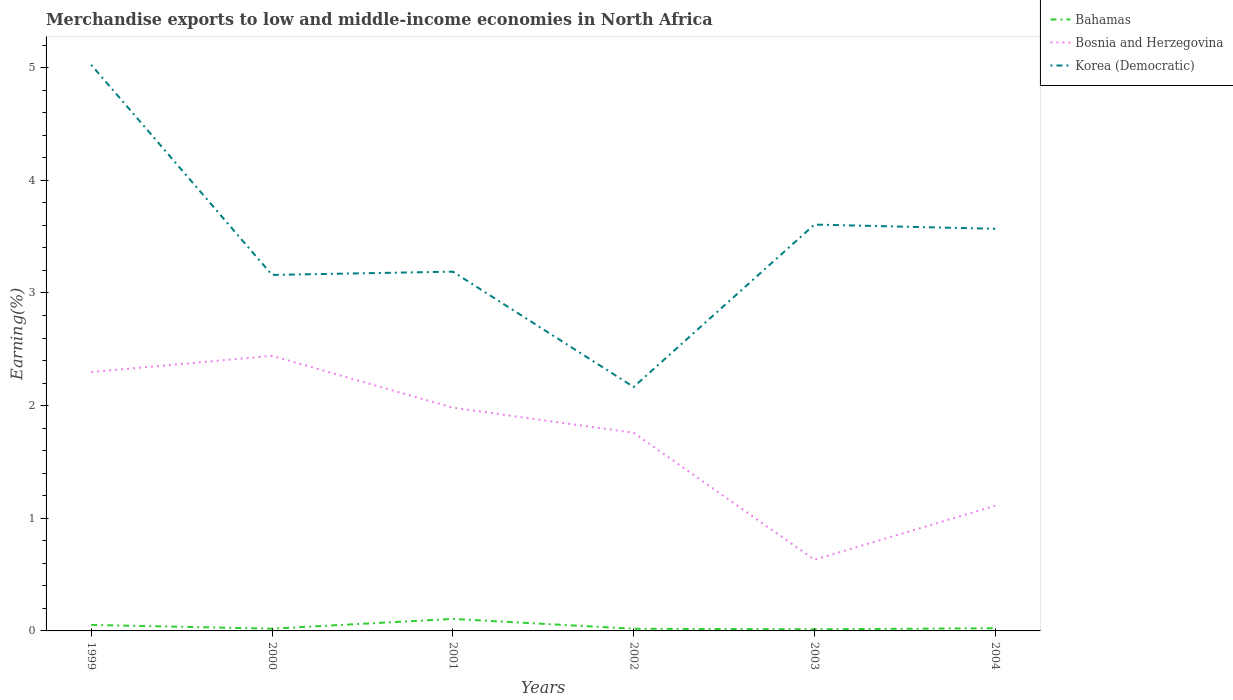Is the number of lines equal to the number of legend labels?
Your answer should be very brief. Yes. Across all years, what is the maximum percentage of amount earned from merchandise exports in Bosnia and Herzegovina?
Keep it short and to the point. 0.63. In which year was the percentage of amount earned from merchandise exports in Bahamas maximum?
Give a very brief answer. 2003. What is the total percentage of amount earned from merchandise exports in Korea (Democratic) in the graph?
Provide a short and direct response. 1.84. What is the difference between the highest and the second highest percentage of amount earned from merchandise exports in Bosnia and Herzegovina?
Give a very brief answer. 1.81. What is the difference between the highest and the lowest percentage of amount earned from merchandise exports in Bosnia and Herzegovina?
Your response must be concise. 4. Is the percentage of amount earned from merchandise exports in Bahamas strictly greater than the percentage of amount earned from merchandise exports in Bosnia and Herzegovina over the years?
Your answer should be compact. Yes. How many lines are there?
Provide a succinct answer. 3. What is the difference between two consecutive major ticks on the Y-axis?
Make the answer very short. 1. Does the graph contain any zero values?
Make the answer very short. No. How many legend labels are there?
Your response must be concise. 3. What is the title of the graph?
Offer a very short reply. Merchandise exports to low and middle-income economies in North Africa. What is the label or title of the Y-axis?
Give a very brief answer. Earning(%). What is the Earning(%) of Bahamas in 1999?
Give a very brief answer. 0.05. What is the Earning(%) in Bosnia and Herzegovina in 1999?
Your answer should be very brief. 2.3. What is the Earning(%) in Korea (Democratic) in 1999?
Your answer should be compact. 5.02. What is the Earning(%) of Bahamas in 2000?
Offer a very short reply. 0.02. What is the Earning(%) of Bosnia and Herzegovina in 2000?
Keep it short and to the point. 2.44. What is the Earning(%) in Korea (Democratic) in 2000?
Your answer should be compact. 3.16. What is the Earning(%) of Bahamas in 2001?
Provide a short and direct response. 0.11. What is the Earning(%) in Bosnia and Herzegovina in 2001?
Offer a very short reply. 1.98. What is the Earning(%) in Korea (Democratic) in 2001?
Ensure brevity in your answer.  3.19. What is the Earning(%) in Bahamas in 2002?
Offer a terse response. 0.02. What is the Earning(%) in Bosnia and Herzegovina in 2002?
Offer a very short reply. 1.76. What is the Earning(%) in Korea (Democratic) in 2002?
Offer a very short reply. 2.17. What is the Earning(%) of Bahamas in 2003?
Make the answer very short. 0.01. What is the Earning(%) in Bosnia and Herzegovina in 2003?
Ensure brevity in your answer.  0.63. What is the Earning(%) in Korea (Democratic) in 2003?
Provide a succinct answer. 3.61. What is the Earning(%) of Bahamas in 2004?
Your answer should be compact. 0.02. What is the Earning(%) in Bosnia and Herzegovina in 2004?
Provide a short and direct response. 1.11. What is the Earning(%) in Korea (Democratic) in 2004?
Your answer should be compact. 3.57. Across all years, what is the maximum Earning(%) of Bahamas?
Give a very brief answer. 0.11. Across all years, what is the maximum Earning(%) of Bosnia and Herzegovina?
Give a very brief answer. 2.44. Across all years, what is the maximum Earning(%) of Korea (Democratic)?
Your response must be concise. 5.02. Across all years, what is the minimum Earning(%) of Bahamas?
Make the answer very short. 0.01. Across all years, what is the minimum Earning(%) in Bosnia and Herzegovina?
Make the answer very short. 0.63. Across all years, what is the minimum Earning(%) of Korea (Democratic)?
Offer a very short reply. 2.17. What is the total Earning(%) of Bahamas in the graph?
Give a very brief answer. 0.24. What is the total Earning(%) of Bosnia and Herzegovina in the graph?
Provide a succinct answer. 10.22. What is the total Earning(%) in Korea (Democratic) in the graph?
Offer a very short reply. 20.72. What is the difference between the Earning(%) of Bahamas in 1999 and that in 2000?
Offer a terse response. 0.03. What is the difference between the Earning(%) in Bosnia and Herzegovina in 1999 and that in 2000?
Provide a succinct answer. -0.14. What is the difference between the Earning(%) in Korea (Democratic) in 1999 and that in 2000?
Your response must be concise. 1.87. What is the difference between the Earning(%) of Bahamas in 1999 and that in 2001?
Offer a terse response. -0.05. What is the difference between the Earning(%) in Bosnia and Herzegovina in 1999 and that in 2001?
Keep it short and to the point. 0.32. What is the difference between the Earning(%) in Korea (Democratic) in 1999 and that in 2001?
Your response must be concise. 1.84. What is the difference between the Earning(%) of Bahamas in 1999 and that in 2002?
Make the answer very short. 0.03. What is the difference between the Earning(%) in Bosnia and Herzegovina in 1999 and that in 2002?
Give a very brief answer. 0.54. What is the difference between the Earning(%) of Korea (Democratic) in 1999 and that in 2002?
Keep it short and to the point. 2.86. What is the difference between the Earning(%) in Bahamas in 1999 and that in 2003?
Provide a succinct answer. 0.04. What is the difference between the Earning(%) of Bosnia and Herzegovina in 1999 and that in 2003?
Provide a succinct answer. 1.67. What is the difference between the Earning(%) in Korea (Democratic) in 1999 and that in 2003?
Offer a very short reply. 1.42. What is the difference between the Earning(%) in Bahamas in 1999 and that in 2004?
Keep it short and to the point. 0.03. What is the difference between the Earning(%) in Bosnia and Herzegovina in 1999 and that in 2004?
Offer a very short reply. 1.19. What is the difference between the Earning(%) of Korea (Democratic) in 1999 and that in 2004?
Make the answer very short. 1.46. What is the difference between the Earning(%) of Bahamas in 2000 and that in 2001?
Ensure brevity in your answer.  -0.09. What is the difference between the Earning(%) in Bosnia and Herzegovina in 2000 and that in 2001?
Ensure brevity in your answer.  0.46. What is the difference between the Earning(%) of Korea (Democratic) in 2000 and that in 2001?
Your response must be concise. -0.03. What is the difference between the Earning(%) in Bahamas in 2000 and that in 2002?
Make the answer very short. 0. What is the difference between the Earning(%) in Bosnia and Herzegovina in 2000 and that in 2002?
Make the answer very short. 0.68. What is the difference between the Earning(%) of Bahamas in 2000 and that in 2003?
Offer a terse response. 0.01. What is the difference between the Earning(%) in Bosnia and Herzegovina in 2000 and that in 2003?
Provide a succinct answer. 1.81. What is the difference between the Earning(%) in Korea (Democratic) in 2000 and that in 2003?
Give a very brief answer. -0.45. What is the difference between the Earning(%) of Bahamas in 2000 and that in 2004?
Ensure brevity in your answer.  -0. What is the difference between the Earning(%) in Bosnia and Herzegovina in 2000 and that in 2004?
Provide a succinct answer. 1.33. What is the difference between the Earning(%) of Korea (Democratic) in 2000 and that in 2004?
Provide a succinct answer. -0.41. What is the difference between the Earning(%) in Bahamas in 2001 and that in 2002?
Offer a very short reply. 0.09. What is the difference between the Earning(%) of Bosnia and Herzegovina in 2001 and that in 2002?
Your answer should be compact. 0.22. What is the difference between the Earning(%) in Korea (Democratic) in 2001 and that in 2002?
Give a very brief answer. 1.02. What is the difference between the Earning(%) of Bahamas in 2001 and that in 2003?
Provide a short and direct response. 0.09. What is the difference between the Earning(%) of Bosnia and Herzegovina in 2001 and that in 2003?
Your answer should be very brief. 1.35. What is the difference between the Earning(%) of Korea (Democratic) in 2001 and that in 2003?
Give a very brief answer. -0.42. What is the difference between the Earning(%) of Bahamas in 2001 and that in 2004?
Offer a very short reply. 0.08. What is the difference between the Earning(%) of Bosnia and Herzegovina in 2001 and that in 2004?
Your answer should be compact. 0.87. What is the difference between the Earning(%) of Korea (Democratic) in 2001 and that in 2004?
Provide a short and direct response. -0.38. What is the difference between the Earning(%) of Bahamas in 2002 and that in 2003?
Keep it short and to the point. 0. What is the difference between the Earning(%) in Bosnia and Herzegovina in 2002 and that in 2003?
Offer a very short reply. 1.13. What is the difference between the Earning(%) of Korea (Democratic) in 2002 and that in 2003?
Your answer should be compact. -1.44. What is the difference between the Earning(%) of Bahamas in 2002 and that in 2004?
Ensure brevity in your answer.  -0. What is the difference between the Earning(%) in Bosnia and Herzegovina in 2002 and that in 2004?
Keep it short and to the point. 0.65. What is the difference between the Earning(%) in Korea (Democratic) in 2002 and that in 2004?
Offer a very short reply. -1.4. What is the difference between the Earning(%) of Bahamas in 2003 and that in 2004?
Keep it short and to the point. -0.01. What is the difference between the Earning(%) of Bosnia and Herzegovina in 2003 and that in 2004?
Offer a terse response. -0.48. What is the difference between the Earning(%) of Korea (Democratic) in 2003 and that in 2004?
Give a very brief answer. 0.04. What is the difference between the Earning(%) of Bahamas in 1999 and the Earning(%) of Bosnia and Herzegovina in 2000?
Your answer should be compact. -2.39. What is the difference between the Earning(%) in Bahamas in 1999 and the Earning(%) in Korea (Democratic) in 2000?
Provide a short and direct response. -3.11. What is the difference between the Earning(%) of Bosnia and Herzegovina in 1999 and the Earning(%) of Korea (Democratic) in 2000?
Provide a short and direct response. -0.86. What is the difference between the Earning(%) of Bahamas in 1999 and the Earning(%) of Bosnia and Herzegovina in 2001?
Make the answer very short. -1.93. What is the difference between the Earning(%) of Bahamas in 1999 and the Earning(%) of Korea (Democratic) in 2001?
Your response must be concise. -3.14. What is the difference between the Earning(%) of Bosnia and Herzegovina in 1999 and the Earning(%) of Korea (Democratic) in 2001?
Offer a terse response. -0.89. What is the difference between the Earning(%) in Bahamas in 1999 and the Earning(%) in Bosnia and Herzegovina in 2002?
Provide a succinct answer. -1.71. What is the difference between the Earning(%) of Bahamas in 1999 and the Earning(%) of Korea (Democratic) in 2002?
Ensure brevity in your answer.  -2.11. What is the difference between the Earning(%) of Bosnia and Herzegovina in 1999 and the Earning(%) of Korea (Democratic) in 2002?
Your answer should be compact. 0.13. What is the difference between the Earning(%) of Bahamas in 1999 and the Earning(%) of Bosnia and Herzegovina in 2003?
Offer a terse response. -0.58. What is the difference between the Earning(%) of Bahamas in 1999 and the Earning(%) of Korea (Democratic) in 2003?
Keep it short and to the point. -3.55. What is the difference between the Earning(%) in Bosnia and Herzegovina in 1999 and the Earning(%) in Korea (Democratic) in 2003?
Ensure brevity in your answer.  -1.31. What is the difference between the Earning(%) of Bahamas in 1999 and the Earning(%) of Bosnia and Herzegovina in 2004?
Offer a very short reply. -1.06. What is the difference between the Earning(%) of Bahamas in 1999 and the Earning(%) of Korea (Democratic) in 2004?
Offer a terse response. -3.52. What is the difference between the Earning(%) of Bosnia and Herzegovina in 1999 and the Earning(%) of Korea (Democratic) in 2004?
Ensure brevity in your answer.  -1.27. What is the difference between the Earning(%) of Bahamas in 2000 and the Earning(%) of Bosnia and Herzegovina in 2001?
Your response must be concise. -1.96. What is the difference between the Earning(%) in Bahamas in 2000 and the Earning(%) in Korea (Democratic) in 2001?
Offer a very short reply. -3.17. What is the difference between the Earning(%) in Bosnia and Herzegovina in 2000 and the Earning(%) in Korea (Democratic) in 2001?
Make the answer very short. -0.75. What is the difference between the Earning(%) of Bahamas in 2000 and the Earning(%) of Bosnia and Herzegovina in 2002?
Ensure brevity in your answer.  -1.74. What is the difference between the Earning(%) of Bahamas in 2000 and the Earning(%) of Korea (Democratic) in 2002?
Make the answer very short. -2.15. What is the difference between the Earning(%) of Bosnia and Herzegovina in 2000 and the Earning(%) of Korea (Democratic) in 2002?
Offer a very short reply. 0.28. What is the difference between the Earning(%) in Bahamas in 2000 and the Earning(%) in Bosnia and Herzegovina in 2003?
Keep it short and to the point. -0.61. What is the difference between the Earning(%) in Bahamas in 2000 and the Earning(%) in Korea (Democratic) in 2003?
Your response must be concise. -3.59. What is the difference between the Earning(%) of Bosnia and Herzegovina in 2000 and the Earning(%) of Korea (Democratic) in 2003?
Provide a succinct answer. -1.17. What is the difference between the Earning(%) of Bahamas in 2000 and the Earning(%) of Bosnia and Herzegovina in 2004?
Provide a succinct answer. -1.09. What is the difference between the Earning(%) in Bahamas in 2000 and the Earning(%) in Korea (Democratic) in 2004?
Offer a very short reply. -3.55. What is the difference between the Earning(%) in Bosnia and Herzegovina in 2000 and the Earning(%) in Korea (Democratic) in 2004?
Your answer should be very brief. -1.13. What is the difference between the Earning(%) of Bahamas in 2001 and the Earning(%) of Bosnia and Herzegovina in 2002?
Your answer should be very brief. -1.65. What is the difference between the Earning(%) of Bahamas in 2001 and the Earning(%) of Korea (Democratic) in 2002?
Offer a very short reply. -2.06. What is the difference between the Earning(%) of Bosnia and Herzegovina in 2001 and the Earning(%) of Korea (Democratic) in 2002?
Make the answer very short. -0.18. What is the difference between the Earning(%) in Bahamas in 2001 and the Earning(%) in Bosnia and Herzegovina in 2003?
Ensure brevity in your answer.  -0.53. What is the difference between the Earning(%) of Bahamas in 2001 and the Earning(%) of Korea (Democratic) in 2003?
Your response must be concise. -3.5. What is the difference between the Earning(%) in Bosnia and Herzegovina in 2001 and the Earning(%) in Korea (Democratic) in 2003?
Offer a very short reply. -1.63. What is the difference between the Earning(%) of Bahamas in 2001 and the Earning(%) of Bosnia and Herzegovina in 2004?
Make the answer very short. -1. What is the difference between the Earning(%) in Bahamas in 2001 and the Earning(%) in Korea (Democratic) in 2004?
Offer a terse response. -3.46. What is the difference between the Earning(%) of Bosnia and Herzegovina in 2001 and the Earning(%) of Korea (Democratic) in 2004?
Provide a short and direct response. -1.59. What is the difference between the Earning(%) in Bahamas in 2002 and the Earning(%) in Bosnia and Herzegovina in 2003?
Your response must be concise. -0.61. What is the difference between the Earning(%) of Bahamas in 2002 and the Earning(%) of Korea (Democratic) in 2003?
Your answer should be very brief. -3.59. What is the difference between the Earning(%) of Bosnia and Herzegovina in 2002 and the Earning(%) of Korea (Democratic) in 2003?
Your response must be concise. -1.85. What is the difference between the Earning(%) in Bahamas in 2002 and the Earning(%) in Bosnia and Herzegovina in 2004?
Provide a short and direct response. -1.09. What is the difference between the Earning(%) in Bahamas in 2002 and the Earning(%) in Korea (Democratic) in 2004?
Your answer should be compact. -3.55. What is the difference between the Earning(%) in Bosnia and Herzegovina in 2002 and the Earning(%) in Korea (Democratic) in 2004?
Your answer should be very brief. -1.81. What is the difference between the Earning(%) of Bahamas in 2003 and the Earning(%) of Bosnia and Herzegovina in 2004?
Offer a terse response. -1.1. What is the difference between the Earning(%) of Bahamas in 2003 and the Earning(%) of Korea (Democratic) in 2004?
Make the answer very short. -3.55. What is the difference between the Earning(%) in Bosnia and Herzegovina in 2003 and the Earning(%) in Korea (Democratic) in 2004?
Make the answer very short. -2.94. What is the average Earning(%) of Bahamas per year?
Make the answer very short. 0.04. What is the average Earning(%) of Bosnia and Herzegovina per year?
Offer a terse response. 1.7. What is the average Earning(%) in Korea (Democratic) per year?
Make the answer very short. 3.45. In the year 1999, what is the difference between the Earning(%) in Bahamas and Earning(%) in Bosnia and Herzegovina?
Your response must be concise. -2.24. In the year 1999, what is the difference between the Earning(%) of Bahamas and Earning(%) of Korea (Democratic)?
Keep it short and to the point. -4.97. In the year 1999, what is the difference between the Earning(%) in Bosnia and Herzegovina and Earning(%) in Korea (Democratic)?
Your answer should be compact. -2.73. In the year 2000, what is the difference between the Earning(%) of Bahamas and Earning(%) of Bosnia and Herzegovina?
Provide a succinct answer. -2.42. In the year 2000, what is the difference between the Earning(%) in Bahamas and Earning(%) in Korea (Democratic)?
Ensure brevity in your answer.  -3.14. In the year 2000, what is the difference between the Earning(%) of Bosnia and Herzegovina and Earning(%) of Korea (Democratic)?
Keep it short and to the point. -0.72. In the year 2001, what is the difference between the Earning(%) of Bahamas and Earning(%) of Bosnia and Herzegovina?
Give a very brief answer. -1.87. In the year 2001, what is the difference between the Earning(%) in Bahamas and Earning(%) in Korea (Democratic)?
Your answer should be compact. -3.08. In the year 2001, what is the difference between the Earning(%) in Bosnia and Herzegovina and Earning(%) in Korea (Democratic)?
Make the answer very short. -1.21. In the year 2002, what is the difference between the Earning(%) in Bahamas and Earning(%) in Bosnia and Herzegovina?
Keep it short and to the point. -1.74. In the year 2002, what is the difference between the Earning(%) in Bahamas and Earning(%) in Korea (Democratic)?
Offer a terse response. -2.15. In the year 2002, what is the difference between the Earning(%) in Bosnia and Herzegovina and Earning(%) in Korea (Democratic)?
Offer a terse response. -0.41. In the year 2003, what is the difference between the Earning(%) of Bahamas and Earning(%) of Bosnia and Herzegovina?
Your answer should be compact. -0.62. In the year 2003, what is the difference between the Earning(%) of Bahamas and Earning(%) of Korea (Democratic)?
Your response must be concise. -3.59. In the year 2003, what is the difference between the Earning(%) of Bosnia and Herzegovina and Earning(%) of Korea (Democratic)?
Your response must be concise. -2.98. In the year 2004, what is the difference between the Earning(%) of Bahamas and Earning(%) of Bosnia and Herzegovina?
Your answer should be very brief. -1.09. In the year 2004, what is the difference between the Earning(%) of Bahamas and Earning(%) of Korea (Democratic)?
Give a very brief answer. -3.54. In the year 2004, what is the difference between the Earning(%) in Bosnia and Herzegovina and Earning(%) in Korea (Democratic)?
Keep it short and to the point. -2.46. What is the ratio of the Earning(%) in Bahamas in 1999 to that in 2000?
Your answer should be compact. 2.63. What is the ratio of the Earning(%) in Bosnia and Herzegovina in 1999 to that in 2000?
Offer a terse response. 0.94. What is the ratio of the Earning(%) of Korea (Democratic) in 1999 to that in 2000?
Offer a terse response. 1.59. What is the ratio of the Earning(%) in Bahamas in 1999 to that in 2001?
Give a very brief answer. 0.5. What is the ratio of the Earning(%) of Bosnia and Herzegovina in 1999 to that in 2001?
Keep it short and to the point. 1.16. What is the ratio of the Earning(%) of Korea (Democratic) in 1999 to that in 2001?
Give a very brief answer. 1.58. What is the ratio of the Earning(%) in Bahamas in 1999 to that in 2002?
Keep it short and to the point. 2.75. What is the ratio of the Earning(%) of Bosnia and Herzegovina in 1999 to that in 2002?
Offer a terse response. 1.31. What is the ratio of the Earning(%) in Korea (Democratic) in 1999 to that in 2002?
Make the answer very short. 2.32. What is the ratio of the Earning(%) in Bahamas in 1999 to that in 2003?
Give a very brief answer. 3.7. What is the ratio of the Earning(%) in Bosnia and Herzegovina in 1999 to that in 2003?
Provide a short and direct response. 3.64. What is the ratio of the Earning(%) of Korea (Democratic) in 1999 to that in 2003?
Ensure brevity in your answer.  1.39. What is the ratio of the Earning(%) in Bahamas in 1999 to that in 2004?
Provide a short and direct response. 2.2. What is the ratio of the Earning(%) in Bosnia and Herzegovina in 1999 to that in 2004?
Offer a very short reply. 2.07. What is the ratio of the Earning(%) of Korea (Democratic) in 1999 to that in 2004?
Offer a very short reply. 1.41. What is the ratio of the Earning(%) in Bahamas in 2000 to that in 2001?
Ensure brevity in your answer.  0.19. What is the ratio of the Earning(%) of Bosnia and Herzegovina in 2000 to that in 2001?
Give a very brief answer. 1.23. What is the ratio of the Earning(%) of Korea (Democratic) in 2000 to that in 2001?
Ensure brevity in your answer.  0.99. What is the ratio of the Earning(%) in Bahamas in 2000 to that in 2002?
Your response must be concise. 1.05. What is the ratio of the Earning(%) of Bosnia and Herzegovina in 2000 to that in 2002?
Offer a terse response. 1.39. What is the ratio of the Earning(%) in Korea (Democratic) in 2000 to that in 2002?
Your answer should be very brief. 1.46. What is the ratio of the Earning(%) of Bahamas in 2000 to that in 2003?
Ensure brevity in your answer.  1.41. What is the ratio of the Earning(%) of Bosnia and Herzegovina in 2000 to that in 2003?
Give a very brief answer. 3.87. What is the ratio of the Earning(%) in Korea (Democratic) in 2000 to that in 2003?
Provide a short and direct response. 0.88. What is the ratio of the Earning(%) of Bahamas in 2000 to that in 2004?
Your answer should be very brief. 0.84. What is the ratio of the Earning(%) in Bosnia and Herzegovina in 2000 to that in 2004?
Your response must be concise. 2.2. What is the ratio of the Earning(%) of Korea (Democratic) in 2000 to that in 2004?
Offer a terse response. 0.89. What is the ratio of the Earning(%) of Bahamas in 2001 to that in 2002?
Offer a very short reply. 5.53. What is the ratio of the Earning(%) in Bosnia and Herzegovina in 2001 to that in 2002?
Provide a short and direct response. 1.13. What is the ratio of the Earning(%) of Korea (Democratic) in 2001 to that in 2002?
Offer a terse response. 1.47. What is the ratio of the Earning(%) in Bahamas in 2001 to that in 2003?
Your answer should be very brief. 7.43. What is the ratio of the Earning(%) of Bosnia and Herzegovina in 2001 to that in 2003?
Provide a succinct answer. 3.14. What is the ratio of the Earning(%) in Korea (Democratic) in 2001 to that in 2003?
Offer a terse response. 0.88. What is the ratio of the Earning(%) in Bahamas in 2001 to that in 2004?
Provide a short and direct response. 4.43. What is the ratio of the Earning(%) of Bosnia and Herzegovina in 2001 to that in 2004?
Provide a short and direct response. 1.78. What is the ratio of the Earning(%) of Korea (Democratic) in 2001 to that in 2004?
Keep it short and to the point. 0.89. What is the ratio of the Earning(%) in Bahamas in 2002 to that in 2003?
Make the answer very short. 1.34. What is the ratio of the Earning(%) of Bosnia and Herzegovina in 2002 to that in 2003?
Offer a terse response. 2.78. What is the ratio of the Earning(%) in Korea (Democratic) in 2002 to that in 2003?
Ensure brevity in your answer.  0.6. What is the ratio of the Earning(%) in Bahamas in 2002 to that in 2004?
Keep it short and to the point. 0.8. What is the ratio of the Earning(%) in Bosnia and Herzegovina in 2002 to that in 2004?
Make the answer very short. 1.58. What is the ratio of the Earning(%) of Korea (Democratic) in 2002 to that in 2004?
Provide a succinct answer. 0.61. What is the ratio of the Earning(%) in Bahamas in 2003 to that in 2004?
Provide a succinct answer. 0.6. What is the ratio of the Earning(%) of Bosnia and Herzegovina in 2003 to that in 2004?
Offer a terse response. 0.57. What is the ratio of the Earning(%) in Korea (Democratic) in 2003 to that in 2004?
Provide a short and direct response. 1.01. What is the difference between the highest and the second highest Earning(%) of Bahamas?
Keep it short and to the point. 0.05. What is the difference between the highest and the second highest Earning(%) in Bosnia and Herzegovina?
Provide a short and direct response. 0.14. What is the difference between the highest and the second highest Earning(%) in Korea (Democratic)?
Keep it short and to the point. 1.42. What is the difference between the highest and the lowest Earning(%) of Bahamas?
Your answer should be compact. 0.09. What is the difference between the highest and the lowest Earning(%) in Bosnia and Herzegovina?
Give a very brief answer. 1.81. What is the difference between the highest and the lowest Earning(%) in Korea (Democratic)?
Offer a very short reply. 2.86. 